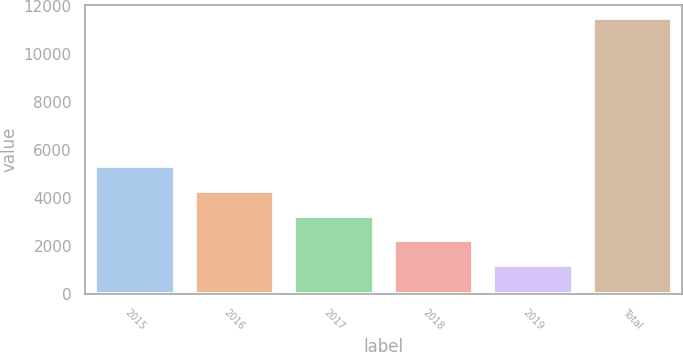Convert chart to OTSL. <chart><loc_0><loc_0><loc_500><loc_500><bar_chart><fcel>2015<fcel>2016<fcel>2017<fcel>2018<fcel>2019<fcel>Total<nl><fcel>5325.6<fcel>4300.2<fcel>3274.8<fcel>2249.4<fcel>1224<fcel>11478<nl></chart> 